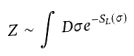Convert formula to latex. <formula><loc_0><loc_0><loc_500><loc_500>Z \sim \int D \sigma e ^ { - S _ { L } \left ( \sigma \right ) }</formula> 